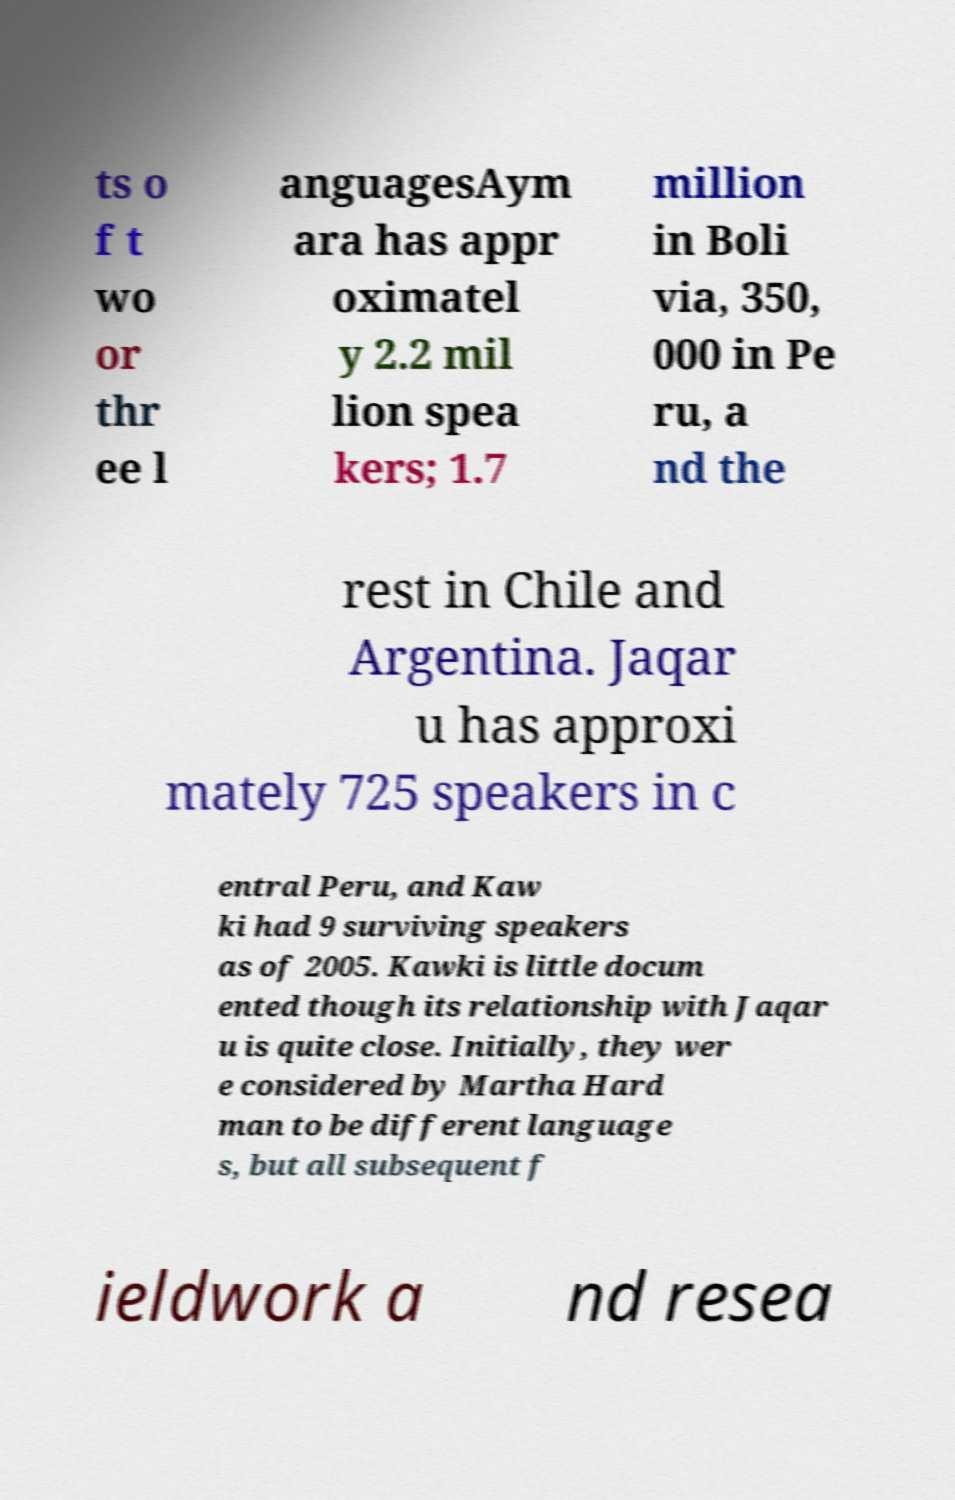Could you extract and type out the text from this image? ts o f t wo or thr ee l anguagesAym ara has appr oximatel y 2.2 mil lion spea kers; 1.7 million in Boli via, 350, 000 in Pe ru, a nd the rest in Chile and Argentina. Jaqar u has approxi mately 725 speakers in c entral Peru, and Kaw ki had 9 surviving speakers as of 2005. Kawki is little docum ented though its relationship with Jaqar u is quite close. Initially, they wer e considered by Martha Hard man to be different language s, but all subsequent f ieldwork a nd resea 